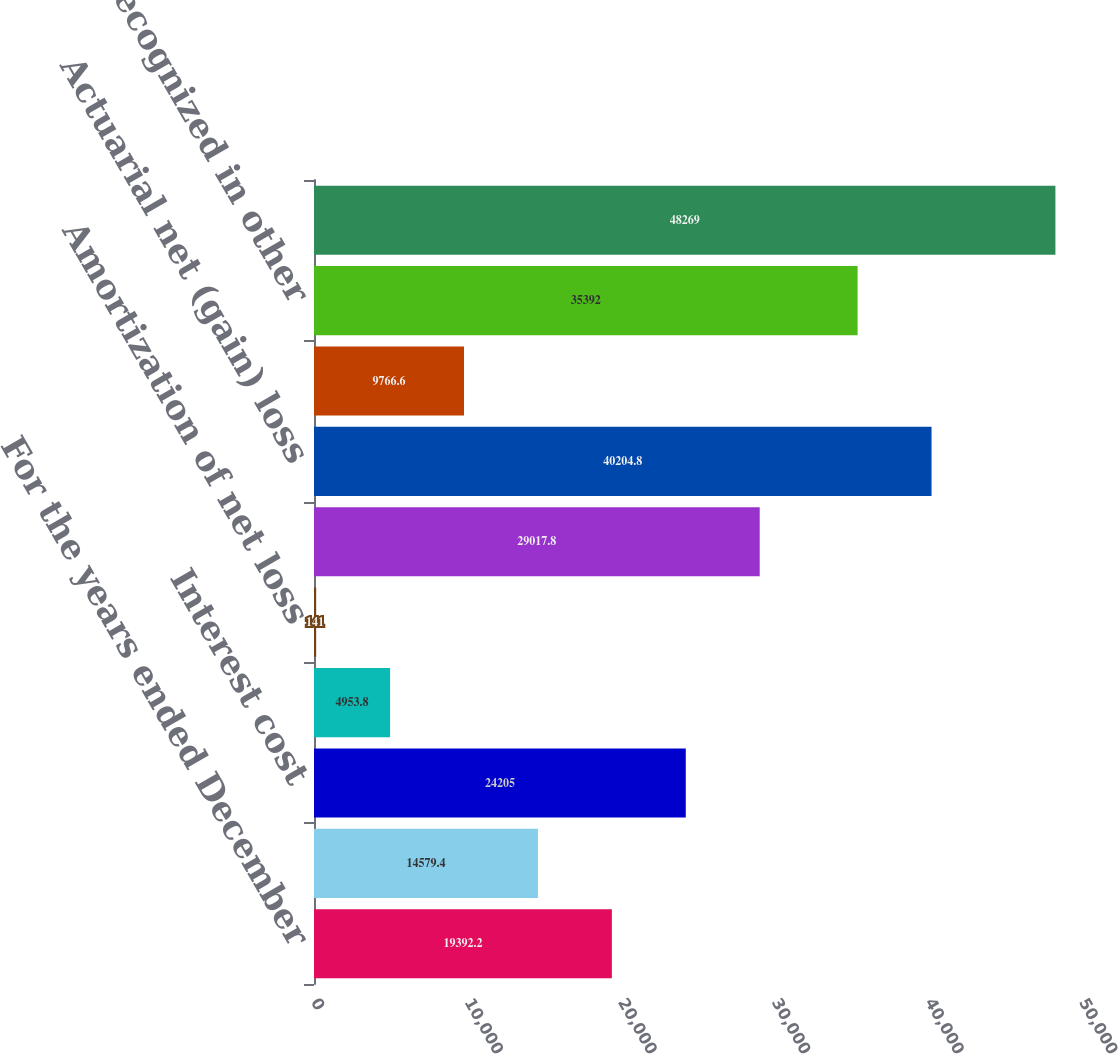Convert chart to OTSL. <chart><loc_0><loc_0><loc_500><loc_500><bar_chart><fcel>For the years ended December<fcel>Service cost<fcel>Interest cost<fcel>Amortization of prior service<fcel>Amortization of net loss<fcel>Total net periodic benefit<fcel>Actuarial net (gain) loss<fcel>Prior service (credit) cost<fcel>Total recognized in other<fcel>Net amounts recognized in<nl><fcel>19392.2<fcel>14579.4<fcel>24205<fcel>4953.8<fcel>141<fcel>29017.8<fcel>40204.8<fcel>9766.6<fcel>35392<fcel>48269<nl></chart> 